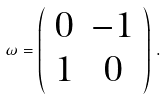Convert formula to latex. <formula><loc_0><loc_0><loc_500><loc_500>\omega = \left ( \begin{array} { c c } 0 & - { 1 } \\ { 1 } & 0 \end{array} \right ) \, .</formula> 